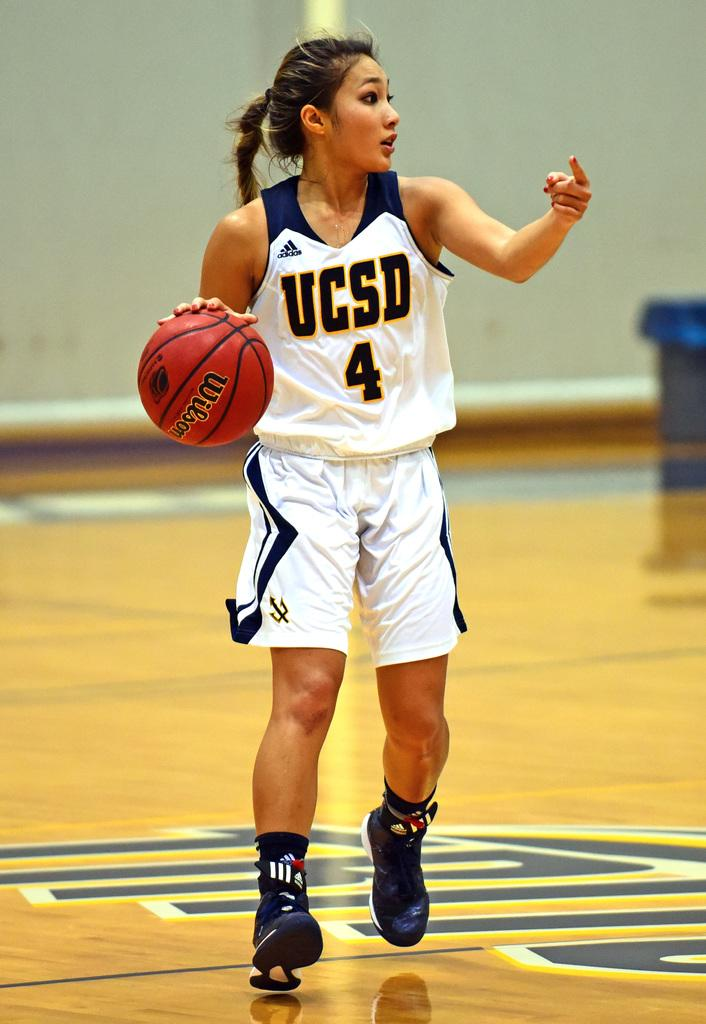<image>
Write a terse but informative summary of the picture. a lady that is playing basketball with the number 4 on 